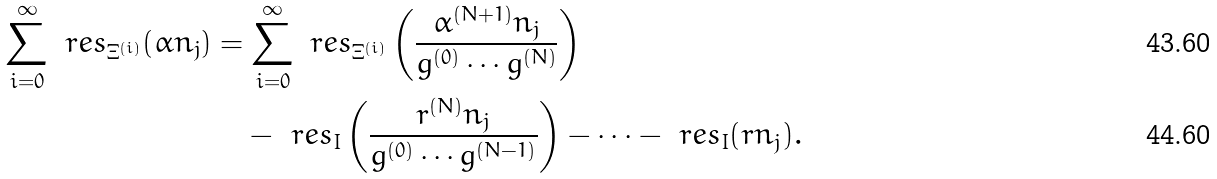<formula> <loc_0><loc_0><loc_500><loc_500>\sum _ { i = 0 } ^ { \infty } \ r e s _ { \Xi ^ { ( i ) } } ( \alpha n _ { j } ) & = \sum _ { i = 0 } ^ { \infty } \ r e s _ { \Xi ^ { ( i ) } } \left ( \frac { \alpha ^ { ( N + 1 ) } n _ { j } } { g ^ { ( 0 ) } \cdots g ^ { ( N ) } } \right ) \\ & \quad - \ r e s _ { I } \left ( \frac { r ^ { ( N ) } n _ { j } } { g ^ { ( 0 ) } \cdots g ^ { ( N - 1 ) } } \right ) - \cdots - \ r e s _ { I } ( r n _ { j } ) .</formula> 